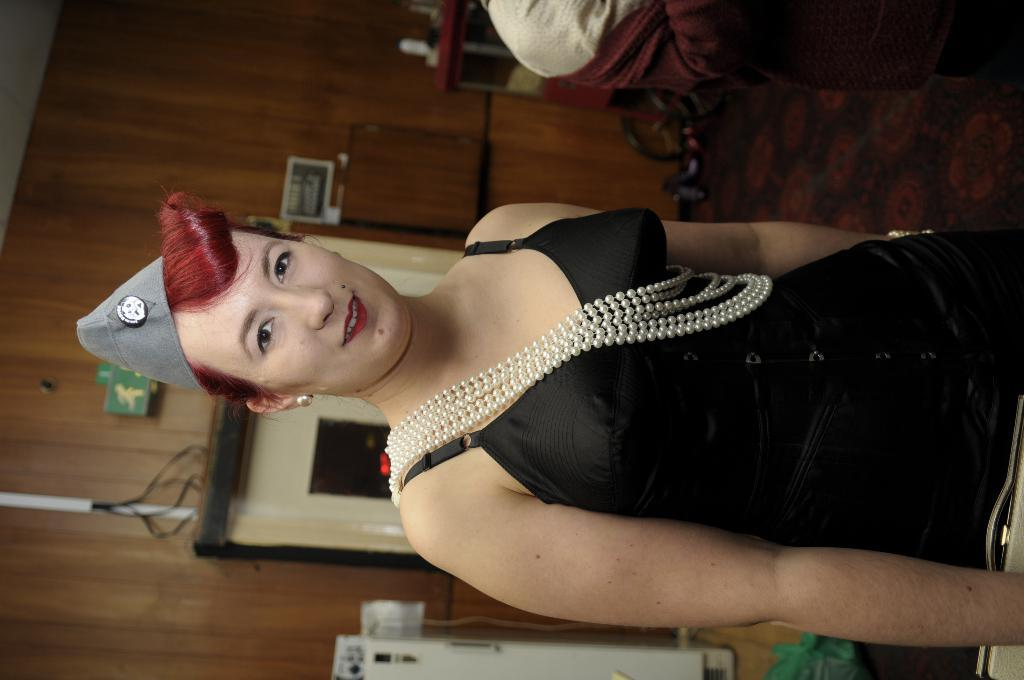Who is present in the image? There is a woman in the image. What is the woman wearing on her head? The woman is wearing a cap. What is the woman's facial expression? The woman is smiling. What can be seen in the background of the image? There is a wall, cables, and some objects visible in the background of the image. What type of tooth is visible in the image? There is no tooth present in the image. 